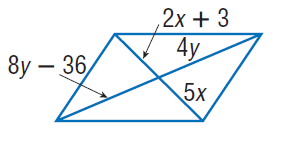Answer the mathemtical geometry problem and directly provide the correct option letter.
Question: Find y so that the quadrilateral is a parallelogram.
Choices: A: 9 B: 18 C: 36 D: 72 A 